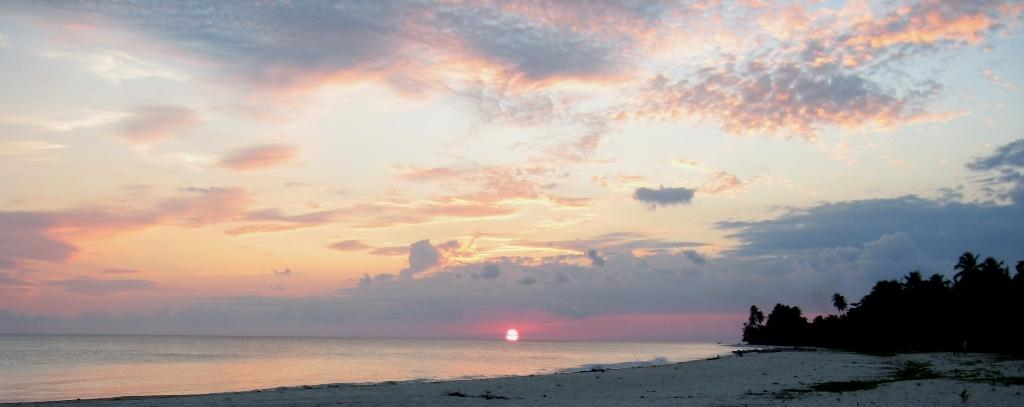What type of natural feature is the main subject of the image? There is an ocean in the image. the image. What other natural elements can be seen in the image? Trees are visible in the image. What is the condition of the sky in the image? Clouds are present in the sky in the image. What type of bird is singing at the event in the image? There is no bird or event present in the image; it features an ocean, trees, and clouds. 